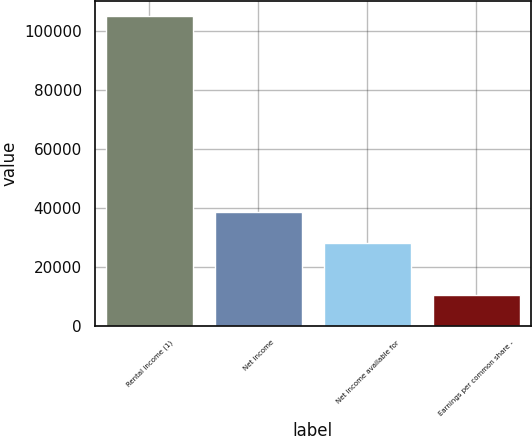Convert chart. <chart><loc_0><loc_0><loc_500><loc_500><bar_chart><fcel>Rental income (1)<fcel>Net income<fcel>Net income available for<fcel>Earnings per common share -<nl><fcel>104964<fcel>38658.3<fcel>28162<fcel>10496.9<nl></chart> 